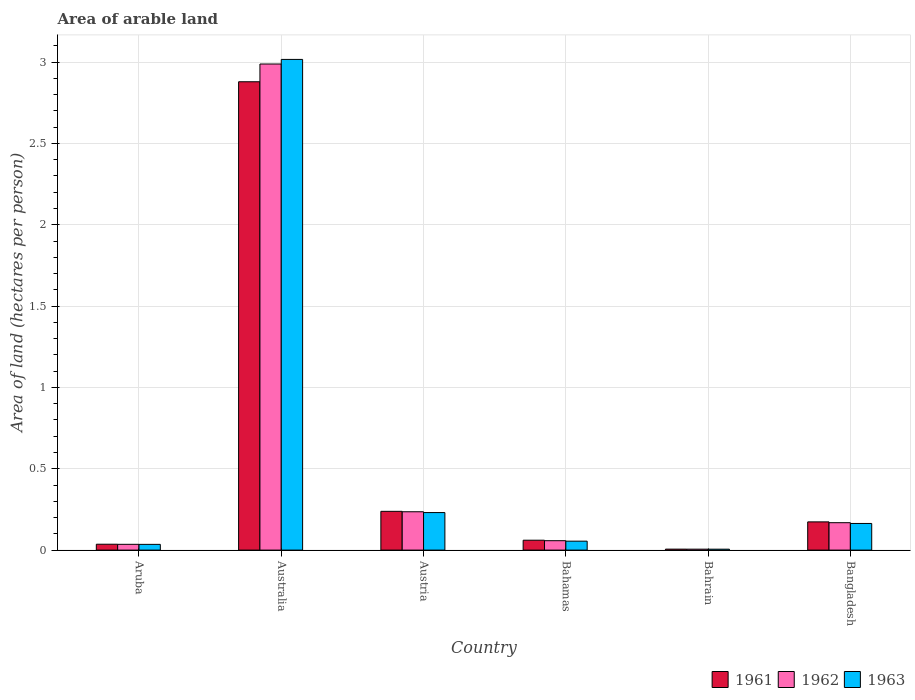Are the number of bars per tick equal to the number of legend labels?
Offer a terse response. Yes. How many bars are there on the 4th tick from the right?
Your answer should be very brief. 3. What is the label of the 6th group of bars from the left?
Give a very brief answer. Bangladesh. In how many cases, is the number of bars for a given country not equal to the number of legend labels?
Give a very brief answer. 0. What is the total arable land in 1962 in Bangladesh?
Give a very brief answer. 0.17. Across all countries, what is the maximum total arable land in 1962?
Offer a very short reply. 2.99. Across all countries, what is the minimum total arable land in 1962?
Make the answer very short. 0.01. In which country was the total arable land in 1963 minimum?
Keep it short and to the point. Bahrain. What is the total total arable land in 1962 in the graph?
Provide a short and direct response. 3.49. What is the difference between the total arable land in 1962 in Bahamas and that in Bangladesh?
Offer a terse response. -0.11. What is the difference between the total arable land in 1963 in Aruba and the total arable land in 1961 in Bangladesh?
Offer a terse response. -0.14. What is the average total arable land in 1961 per country?
Offer a very short reply. 0.57. What is the difference between the total arable land of/in 1961 and total arable land of/in 1963 in Bahrain?
Provide a succinct answer. 0. In how many countries, is the total arable land in 1961 greater than 1.9 hectares per person?
Ensure brevity in your answer.  1. What is the ratio of the total arable land in 1961 in Austria to that in Bangladesh?
Keep it short and to the point. 1.37. What is the difference between the highest and the second highest total arable land in 1962?
Make the answer very short. -2.75. What is the difference between the highest and the lowest total arable land in 1961?
Make the answer very short. 2.87. In how many countries, is the total arable land in 1962 greater than the average total arable land in 1962 taken over all countries?
Provide a succinct answer. 1. What does the 3rd bar from the right in Australia represents?
Give a very brief answer. 1961. Is it the case that in every country, the sum of the total arable land in 1961 and total arable land in 1962 is greater than the total arable land in 1963?
Ensure brevity in your answer.  Yes. How many bars are there?
Give a very brief answer. 18. Are all the bars in the graph horizontal?
Ensure brevity in your answer.  No. What is the difference between two consecutive major ticks on the Y-axis?
Your answer should be very brief. 0.5. Are the values on the major ticks of Y-axis written in scientific E-notation?
Give a very brief answer. No. Does the graph contain any zero values?
Give a very brief answer. No. Where does the legend appear in the graph?
Your answer should be compact. Bottom right. What is the title of the graph?
Make the answer very short. Area of arable land. Does "1972" appear as one of the legend labels in the graph?
Provide a succinct answer. No. What is the label or title of the Y-axis?
Keep it short and to the point. Area of land (hectares per person). What is the Area of land (hectares per person) of 1961 in Aruba?
Your response must be concise. 0.04. What is the Area of land (hectares per person) of 1962 in Aruba?
Offer a very short reply. 0.04. What is the Area of land (hectares per person) of 1963 in Aruba?
Offer a very short reply. 0.04. What is the Area of land (hectares per person) in 1961 in Australia?
Your answer should be very brief. 2.88. What is the Area of land (hectares per person) in 1962 in Australia?
Give a very brief answer. 2.99. What is the Area of land (hectares per person) of 1963 in Australia?
Give a very brief answer. 3.02. What is the Area of land (hectares per person) of 1961 in Austria?
Your answer should be very brief. 0.24. What is the Area of land (hectares per person) in 1962 in Austria?
Provide a short and direct response. 0.24. What is the Area of land (hectares per person) in 1963 in Austria?
Ensure brevity in your answer.  0.23. What is the Area of land (hectares per person) of 1961 in Bahamas?
Ensure brevity in your answer.  0.06. What is the Area of land (hectares per person) in 1962 in Bahamas?
Your response must be concise. 0.06. What is the Area of land (hectares per person) of 1963 in Bahamas?
Your answer should be compact. 0.05. What is the Area of land (hectares per person) in 1961 in Bahrain?
Your response must be concise. 0.01. What is the Area of land (hectares per person) of 1962 in Bahrain?
Offer a very short reply. 0.01. What is the Area of land (hectares per person) of 1963 in Bahrain?
Make the answer very short. 0.01. What is the Area of land (hectares per person) of 1961 in Bangladesh?
Make the answer very short. 0.17. What is the Area of land (hectares per person) of 1962 in Bangladesh?
Provide a succinct answer. 0.17. What is the Area of land (hectares per person) in 1963 in Bangladesh?
Ensure brevity in your answer.  0.16. Across all countries, what is the maximum Area of land (hectares per person) of 1961?
Your response must be concise. 2.88. Across all countries, what is the maximum Area of land (hectares per person) in 1962?
Your answer should be compact. 2.99. Across all countries, what is the maximum Area of land (hectares per person) in 1963?
Offer a very short reply. 3.02. Across all countries, what is the minimum Area of land (hectares per person) in 1961?
Provide a short and direct response. 0.01. Across all countries, what is the minimum Area of land (hectares per person) of 1962?
Your answer should be very brief. 0.01. Across all countries, what is the minimum Area of land (hectares per person) in 1963?
Provide a succinct answer. 0.01. What is the total Area of land (hectares per person) of 1961 in the graph?
Your answer should be compact. 3.39. What is the total Area of land (hectares per person) of 1962 in the graph?
Offer a very short reply. 3.49. What is the total Area of land (hectares per person) in 1963 in the graph?
Ensure brevity in your answer.  3.51. What is the difference between the Area of land (hectares per person) in 1961 in Aruba and that in Australia?
Ensure brevity in your answer.  -2.84. What is the difference between the Area of land (hectares per person) of 1962 in Aruba and that in Australia?
Provide a succinct answer. -2.95. What is the difference between the Area of land (hectares per person) of 1963 in Aruba and that in Australia?
Make the answer very short. -2.98. What is the difference between the Area of land (hectares per person) in 1961 in Aruba and that in Austria?
Provide a succinct answer. -0.2. What is the difference between the Area of land (hectares per person) in 1962 in Aruba and that in Austria?
Provide a short and direct response. -0.2. What is the difference between the Area of land (hectares per person) in 1963 in Aruba and that in Austria?
Provide a short and direct response. -0.2. What is the difference between the Area of land (hectares per person) of 1961 in Aruba and that in Bahamas?
Your answer should be compact. -0.02. What is the difference between the Area of land (hectares per person) in 1962 in Aruba and that in Bahamas?
Give a very brief answer. -0.02. What is the difference between the Area of land (hectares per person) of 1963 in Aruba and that in Bahamas?
Ensure brevity in your answer.  -0.02. What is the difference between the Area of land (hectares per person) in 1961 in Aruba and that in Bahrain?
Offer a very short reply. 0.03. What is the difference between the Area of land (hectares per person) in 1962 in Aruba and that in Bahrain?
Provide a succinct answer. 0.03. What is the difference between the Area of land (hectares per person) of 1963 in Aruba and that in Bahrain?
Your answer should be compact. 0.03. What is the difference between the Area of land (hectares per person) in 1961 in Aruba and that in Bangladesh?
Your response must be concise. -0.14. What is the difference between the Area of land (hectares per person) in 1962 in Aruba and that in Bangladesh?
Keep it short and to the point. -0.13. What is the difference between the Area of land (hectares per person) of 1963 in Aruba and that in Bangladesh?
Keep it short and to the point. -0.13. What is the difference between the Area of land (hectares per person) in 1961 in Australia and that in Austria?
Make the answer very short. 2.64. What is the difference between the Area of land (hectares per person) of 1962 in Australia and that in Austria?
Your response must be concise. 2.75. What is the difference between the Area of land (hectares per person) of 1963 in Australia and that in Austria?
Your answer should be compact. 2.79. What is the difference between the Area of land (hectares per person) in 1961 in Australia and that in Bahamas?
Your answer should be compact. 2.82. What is the difference between the Area of land (hectares per person) in 1962 in Australia and that in Bahamas?
Provide a succinct answer. 2.93. What is the difference between the Area of land (hectares per person) of 1963 in Australia and that in Bahamas?
Give a very brief answer. 2.96. What is the difference between the Area of land (hectares per person) in 1961 in Australia and that in Bahrain?
Offer a terse response. 2.87. What is the difference between the Area of land (hectares per person) in 1962 in Australia and that in Bahrain?
Your answer should be compact. 2.98. What is the difference between the Area of land (hectares per person) of 1963 in Australia and that in Bahrain?
Your answer should be compact. 3.01. What is the difference between the Area of land (hectares per person) of 1961 in Australia and that in Bangladesh?
Give a very brief answer. 2.71. What is the difference between the Area of land (hectares per person) of 1962 in Australia and that in Bangladesh?
Your answer should be compact. 2.82. What is the difference between the Area of land (hectares per person) of 1963 in Australia and that in Bangladesh?
Offer a very short reply. 2.85. What is the difference between the Area of land (hectares per person) of 1961 in Austria and that in Bahamas?
Keep it short and to the point. 0.18. What is the difference between the Area of land (hectares per person) in 1962 in Austria and that in Bahamas?
Your answer should be compact. 0.18. What is the difference between the Area of land (hectares per person) of 1963 in Austria and that in Bahamas?
Make the answer very short. 0.18. What is the difference between the Area of land (hectares per person) of 1961 in Austria and that in Bahrain?
Your answer should be compact. 0.23. What is the difference between the Area of land (hectares per person) in 1962 in Austria and that in Bahrain?
Give a very brief answer. 0.23. What is the difference between the Area of land (hectares per person) in 1963 in Austria and that in Bahrain?
Offer a terse response. 0.23. What is the difference between the Area of land (hectares per person) of 1961 in Austria and that in Bangladesh?
Provide a short and direct response. 0.06. What is the difference between the Area of land (hectares per person) in 1962 in Austria and that in Bangladesh?
Keep it short and to the point. 0.07. What is the difference between the Area of land (hectares per person) of 1963 in Austria and that in Bangladesh?
Provide a short and direct response. 0.07. What is the difference between the Area of land (hectares per person) in 1961 in Bahamas and that in Bahrain?
Provide a succinct answer. 0.05. What is the difference between the Area of land (hectares per person) of 1962 in Bahamas and that in Bahrain?
Provide a succinct answer. 0.05. What is the difference between the Area of land (hectares per person) in 1963 in Bahamas and that in Bahrain?
Your response must be concise. 0.05. What is the difference between the Area of land (hectares per person) in 1961 in Bahamas and that in Bangladesh?
Provide a short and direct response. -0.11. What is the difference between the Area of land (hectares per person) of 1962 in Bahamas and that in Bangladesh?
Provide a short and direct response. -0.11. What is the difference between the Area of land (hectares per person) in 1963 in Bahamas and that in Bangladesh?
Your answer should be very brief. -0.11. What is the difference between the Area of land (hectares per person) of 1961 in Bahrain and that in Bangladesh?
Offer a terse response. -0.17. What is the difference between the Area of land (hectares per person) in 1962 in Bahrain and that in Bangladesh?
Offer a terse response. -0.16. What is the difference between the Area of land (hectares per person) of 1963 in Bahrain and that in Bangladesh?
Provide a short and direct response. -0.16. What is the difference between the Area of land (hectares per person) in 1961 in Aruba and the Area of land (hectares per person) in 1962 in Australia?
Make the answer very short. -2.95. What is the difference between the Area of land (hectares per person) of 1961 in Aruba and the Area of land (hectares per person) of 1963 in Australia?
Provide a succinct answer. -2.98. What is the difference between the Area of land (hectares per person) of 1962 in Aruba and the Area of land (hectares per person) of 1963 in Australia?
Your answer should be very brief. -2.98. What is the difference between the Area of land (hectares per person) in 1961 in Aruba and the Area of land (hectares per person) in 1962 in Austria?
Ensure brevity in your answer.  -0.2. What is the difference between the Area of land (hectares per person) in 1961 in Aruba and the Area of land (hectares per person) in 1963 in Austria?
Offer a very short reply. -0.19. What is the difference between the Area of land (hectares per person) of 1962 in Aruba and the Area of land (hectares per person) of 1963 in Austria?
Ensure brevity in your answer.  -0.2. What is the difference between the Area of land (hectares per person) in 1961 in Aruba and the Area of land (hectares per person) in 1962 in Bahamas?
Offer a very short reply. -0.02. What is the difference between the Area of land (hectares per person) in 1961 in Aruba and the Area of land (hectares per person) in 1963 in Bahamas?
Keep it short and to the point. -0.02. What is the difference between the Area of land (hectares per person) in 1962 in Aruba and the Area of land (hectares per person) in 1963 in Bahamas?
Give a very brief answer. -0.02. What is the difference between the Area of land (hectares per person) in 1961 in Aruba and the Area of land (hectares per person) in 1962 in Bahrain?
Provide a succinct answer. 0.03. What is the difference between the Area of land (hectares per person) in 1961 in Aruba and the Area of land (hectares per person) in 1963 in Bahrain?
Give a very brief answer. 0.03. What is the difference between the Area of land (hectares per person) in 1961 in Aruba and the Area of land (hectares per person) in 1962 in Bangladesh?
Give a very brief answer. -0.13. What is the difference between the Area of land (hectares per person) of 1961 in Aruba and the Area of land (hectares per person) of 1963 in Bangladesh?
Ensure brevity in your answer.  -0.13. What is the difference between the Area of land (hectares per person) in 1962 in Aruba and the Area of land (hectares per person) in 1963 in Bangladesh?
Offer a terse response. -0.13. What is the difference between the Area of land (hectares per person) in 1961 in Australia and the Area of land (hectares per person) in 1962 in Austria?
Your answer should be very brief. 2.64. What is the difference between the Area of land (hectares per person) in 1961 in Australia and the Area of land (hectares per person) in 1963 in Austria?
Keep it short and to the point. 2.65. What is the difference between the Area of land (hectares per person) of 1962 in Australia and the Area of land (hectares per person) of 1963 in Austria?
Your response must be concise. 2.76. What is the difference between the Area of land (hectares per person) of 1961 in Australia and the Area of land (hectares per person) of 1962 in Bahamas?
Provide a succinct answer. 2.82. What is the difference between the Area of land (hectares per person) of 1961 in Australia and the Area of land (hectares per person) of 1963 in Bahamas?
Your answer should be very brief. 2.82. What is the difference between the Area of land (hectares per person) in 1962 in Australia and the Area of land (hectares per person) in 1963 in Bahamas?
Offer a terse response. 2.93. What is the difference between the Area of land (hectares per person) in 1961 in Australia and the Area of land (hectares per person) in 1962 in Bahrain?
Your response must be concise. 2.87. What is the difference between the Area of land (hectares per person) in 1961 in Australia and the Area of land (hectares per person) in 1963 in Bahrain?
Give a very brief answer. 2.87. What is the difference between the Area of land (hectares per person) in 1962 in Australia and the Area of land (hectares per person) in 1963 in Bahrain?
Keep it short and to the point. 2.98. What is the difference between the Area of land (hectares per person) of 1961 in Australia and the Area of land (hectares per person) of 1962 in Bangladesh?
Give a very brief answer. 2.71. What is the difference between the Area of land (hectares per person) in 1961 in Australia and the Area of land (hectares per person) in 1963 in Bangladesh?
Your response must be concise. 2.72. What is the difference between the Area of land (hectares per person) in 1962 in Australia and the Area of land (hectares per person) in 1963 in Bangladesh?
Your answer should be very brief. 2.82. What is the difference between the Area of land (hectares per person) in 1961 in Austria and the Area of land (hectares per person) in 1962 in Bahamas?
Provide a short and direct response. 0.18. What is the difference between the Area of land (hectares per person) of 1961 in Austria and the Area of land (hectares per person) of 1963 in Bahamas?
Provide a short and direct response. 0.18. What is the difference between the Area of land (hectares per person) of 1962 in Austria and the Area of land (hectares per person) of 1963 in Bahamas?
Provide a succinct answer. 0.18. What is the difference between the Area of land (hectares per person) in 1961 in Austria and the Area of land (hectares per person) in 1962 in Bahrain?
Your answer should be very brief. 0.23. What is the difference between the Area of land (hectares per person) of 1961 in Austria and the Area of land (hectares per person) of 1963 in Bahrain?
Your answer should be very brief. 0.23. What is the difference between the Area of land (hectares per person) of 1962 in Austria and the Area of land (hectares per person) of 1963 in Bahrain?
Give a very brief answer. 0.23. What is the difference between the Area of land (hectares per person) of 1961 in Austria and the Area of land (hectares per person) of 1962 in Bangladesh?
Provide a succinct answer. 0.07. What is the difference between the Area of land (hectares per person) in 1961 in Austria and the Area of land (hectares per person) in 1963 in Bangladesh?
Provide a succinct answer. 0.07. What is the difference between the Area of land (hectares per person) in 1962 in Austria and the Area of land (hectares per person) in 1963 in Bangladesh?
Your response must be concise. 0.07. What is the difference between the Area of land (hectares per person) of 1961 in Bahamas and the Area of land (hectares per person) of 1962 in Bahrain?
Provide a succinct answer. 0.06. What is the difference between the Area of land (hectares per person) in 1961 in Bahamas and the Area of land (hectares per person) in 1963 in Bahrain?
Give a very brief answer. 0.06. What is the difference between the Area of land (hectares per person) in 1962 in Bahamas and the Area of land (hectares per person) in 1963 in Bahrain?
Your response must be concise. 0.05. What is the difference between the Area of land (hectares per person) in 1961 in Bahamas and the Area of land (hectares per person) in 1962 in Bangladesh?
Your answer should be very brief. -0.11. What is the difference between the Area of land (hectares per person) in 1961 in Bahamas and the Area of land (hectares per person) in 1963 in Bangladesh?
Give a very brief answer. -0.1. What is the difference between the Area of land (hectares per person) in 1962 in Bahamas and the Area of land (hectares per person) in 1963 in Bangladesh?
Offer a terse response. -0.11. What is the difference between the Area of land (hectares per person) in 1961 in Bahrain and the Area of land (hectares per person) in 1962 in Bangladesh?
Keep it short and to the point. -0.16. What is the difference between the Area of land (hectares per person) in 1961 in Bahrain and the Area of land (hectares per person) in 1963 in Bangladesh?
Your answer should be very brief. -0.16. What is the difference between the Area of land (hectares per person) of 1962 in Bahrain and the Area of land (hectares per person) of 1963 in Bangladesh?
Ensure brevity in your answer.  -0.16. What is the average Area of land (hectares per person) of 1961 per country?
Your answer should be very brief. 0.57. What is the average Area of land (hectares per person) in 1962 per country?
Offer a very short reply. 0.58. What is the average Area of land (hectares per person) of 1963 per country?
Offer a very short reply. 0.58. What is the difference between the Area of land (hectares per person) in 1961 and Area of land (hectares per person) in 1962 in Aruba?
Your response must be concise. 0. What is the difference between the Area of land (hectares per person) of 1961 and Area of land (hectares per person) of 1963 in Aruba?
Provide a succinct answer. 0. What is the difference between the Area of land (hectares per person) of 1961 and Area of land (hectares per person) of 1962 in Australia?
Provide a succinct answer. -0.11. What is the difference between the Area of land (hectares per person) in 1961 and Area of land (hectares per person) in 1963 in Australia?
Make the answer very short. -0.14. What is the difference between the Area of land (hectares per person) in 1962 and Area of land (hectares per person) in 1963 in Australia?
Keep it short and to the point. -0.03. What is the difference between the Area of land (hectares per person) in 1961 and Area of land (hectares per person) in 1962 in Austria?
Give a very brief answer. 0. What is the difference between the Area of land (hectares per person) of 1961 and Area of land (hectares per person) of 1963 in Austria?
Keep it short and to the point. 0.01. What is the difference between the Area of land (hectares per person) of 1962 and Area of land (hectares per person) of 1963 in Austria?
Your response must be concise. 0.01. What is the difference between the Area of land (hectares per person) of 1961 and Area of land (hectares per person) of 1962 in Bahamas?
Your answer should be very brief. 0. What is the difference between the Area of land (hectares per person) in 1961 and Area of land (hectares per person) in 1963 in Bahamas?
Your answer should be compact. 0.01. What is the difference between the Area of land (hectares per person) in 1962 and Area of land (hectares per person) in 1963 in Bahamas?
Your response must be concise. 0. What is the difference between the Area of land (hectares per person) of 1961 and Area of land (hectares per person) of 1962 in Bahrain?
Your response must be concise. 0. What is the difference between the Area of land (hectares per person) of 1961 and Area of land (hectares per person) of 1963 in Bahrain?
Ensure brevity in your answer.  0. What is the difference between the Area of land (hectares per person) of 1962 and Area of land (hectares per person) of 1963 in Bahrain?
Your answer should be very brief. 0. What is the difference between the Area of land (hectares per person) in 1961 and Area of land (hectares per person) in 1962 in Bangladesh?
Keep it short and to the point. 0.01. What is the difference between the Area of land (hectares per person) in 1961 and Area of land (hectares per person) in 1963 in Bangladesh?
Keep it short and to the point. 0.01. What is the difference between the Area of land (hectares per person) of 1962 and Area of land (hectares per person) of 1963 in Bangladesh?
Your answer should be very brief. 0. What is the ratio of the Area of land (hectares per person) of 1961 in Aruba to that in Australia?
Keep it short and to the point. 0.01. What is the ratio of the Area of land (hectares per person) in 1962 in Aruba to that in Australia?
Your response must be concise. 0.01. What is the ratio of the Area of land (hectares per person) in 1963 in Aruba to that in Australia?
Keep it short and to the point. 0.01. What is the ratio of the Area of land (hectares per person) of 1961 in Aruba to that in Austria?
Give a very brief answer. 0.15. What is the ratio of the Area of land (hectares per person) of 1962 in Aruba to that in Austria?
Your response must be concise. 0.15. What is the ratio of the Area of land (hectares per person) in 1963 in Aruba to that in Austria?
Keep it short and to the point. 0.15. What is the ratio of the Area of land (hectares per person) in 1961 in Aruba to that in Bahamas?
Provide a short and direct response. 0.59. What is the ratio of the Area of land (hectares per person) in 1962 in Aruba to that in Bahamas?
Your answer should be very brief. 0.62. What is the ratio of the Area of land (hectares per person) in 1963 in Aruba to that in Bahamas?
Provide a succinct answer. 0.64. What is the ratio of the Area of land (hectares per person) in 1961 in Aruba to that in Bahrain?
Give a very brief answer. 6.06. What is the ratio of the Area of land (hectares per person) in 1962 in Aruba to that in Bahrain?
Provide a succinct answer. 6.16. What is the ratio of the Area of land (hectares per person) in 1963 in Aruba to that in Bahrain?
Your answer should be very brief. 6.28. What is the ratio of the Area of land (hectares per person) in 1961 in Aruba to that in Bangladesh?
Make the answer very short. 0.21. What is the ratio of the Area of land (hectares per person) of 1962 in Aruba to that in Bangladesh?
Your response must be concise. 0.21. What is the ratio of the Area of land (hectares per person) of 1963 in Aruba to that in Bangladesh?
Give a very brief answer. 0.22. What is the ratio of the Area of land (hectares per person) of 1961 in Australia to that in Austria?
Your answer should be very brief. 12.08. What is the ratio of the Area of land (hectares per person) of 1962 in Australia to that in Austria?
Keep it short and to the point. 12.68. What is the ratio of the Area of land (hectares per person) in 1963 in Australia to that in Austria?
Provide a succinct answer. 13.07. What is the ratio of the Area of land (hectares per person) of 1961 in Australia to that in Bahamas?
Offer a terse response. 47.35. What is the ratio of the Area of land (hectares per person) of 1962 in Australia to that in Bahamas?
Your answer should be very brief. 51.69. What is the ratio of the Area of land (hectares per person) in 1963 in Australia to that in Bahamas?
Offer a very short reply. 54.88. What is the ratio of the Area of land (hectares per person) of 1961 in Australia to that in Bahrain?
Keep it short and to the point. 483.52. What is the ratio of the Area of land (hectares per person) of 1962 in Australia to that in Bahrain?
Make the answer very short. 517.34. What is the ratio of the Area of land (hectares per person) in 1963 in Australia to that in Bahrain?
Provide a succinct answer. 537.14. What is the ratio of the Area of land (hectares per person) of 1961 in Australia to that in Bangladesh?
Provide a short and direct response. 16.6. What is the ratio of the Area of land (hectares per person) in 1962 in Australia to that in Bangladesh?
Offer a terse response. 17.74. What is the ratio of the Area of land (hectares per person) in 1963 in Australia to that in Bangladesh?
Give a very brief answer. 18.42. What is the ratio of the Area of land (hectares per person) in 1961 in Austria to that in Bahamas?
Make the answer very short. 3.92. What is the ratio of the Area of land (hectares per person) of 1962 in Austria to that in Bahamas?
Offer a very short reply. 4.08. What is the ratio of the Area of land (hectares per person) in 1963 in Austria to that in Bahamas?
Make the answer very short. 4.2. What is the ratio of the Area of land (hectares per person) in 1961 in Austria to that in Bahrain?
Your response must be concise. 40.02. What is the ratio of the Area of land (hectares per person) of 1962 in Austria to that in Bahrain?
Your answer should be compact. 40.81. What is the ratio of the Area of land (hectares per person) of 1963 in Austria to that in Bahrain?
Give a very brief answer. 41.09. What is the ratio of the Area of land (hectares per person) of 1961 in Austria to that in Bangladesh?
Ensure brevity in your answer.  1.37. What is the ratio of the Area of land (hectares per person) of 1962 in Austria to that in Bangladesh?
Your answer should be very brief. 1.4. What is the ratio of the Area of land (hectares per person) of 1963 in Austria to that in Bangladesh?
Make the answer very short. 1.41. What is the ratio of the Area of land (hectares per person) in 1961 in Bahamas to that in Bahrain?
Ensure brevity in your answer.  10.21. What is the ratio of the Area of land (hectares per person) in 1962 in Bahamas to that in Bahrain?
Your response must be concise. 10.01. What is the ratio of the Area of land (hectares per person) in 1963 in Bahamas to that in Bahrain?
Provide a short and direct response. 9.79. What is the ratio of the Area of land (hectares per person) in 1961 in Bahamas to that in Bangladesh?
Your answer should be compact. 0.35. What is the ratio of the Area of land (hectares per person) in 1962 in Bahamas to that in Bangladesh?
Offer a terse response. 0.34. What is the ratio of the Area of land (hectares per person) in 1963 in Bahamas to that in Bangladesh?
Give a very brief answer. 0.34. What is the ratio of the Area of land (hectares per person) of 1961 in Bahrain to that in Bangladesh?
Your answer should be very brief. 0.03. What is the ratio of the Area of land (hectares per person) of 1962 in Bahrain to that in Bangladesh?
Offer a terse response. 0.03. What is the ratio of the Area of land (hectares per person) of 1963 in Bahrain to that in Bangladesh?
Offer a very short reply. 0.03. What is the difference between the highest and the second highest Area of land (hectares per person) in 1961?
Your answer should be very brief. 2.64. What is the difference between the highest and the second highest Area of land (hectares per person) in 1962?
Your answer should be compact. 2.75. What is the difference between the highest and the second highest Area of land (hectares per person) in 1963?
Provide a short and direct response. 2.79. What is the difference between the highest and the lowest Area of land (hectares per person) of 1961?
Make the answer very short. 2.87. What is the difference between the highest and the lowest Area of land (hectares per person) of 1962?
Offer a very short reply. 2.98. What is the difference between the highest and the lowest Area of land (hectares per person) of 1963?
Give a very brief answer. 3.01. 